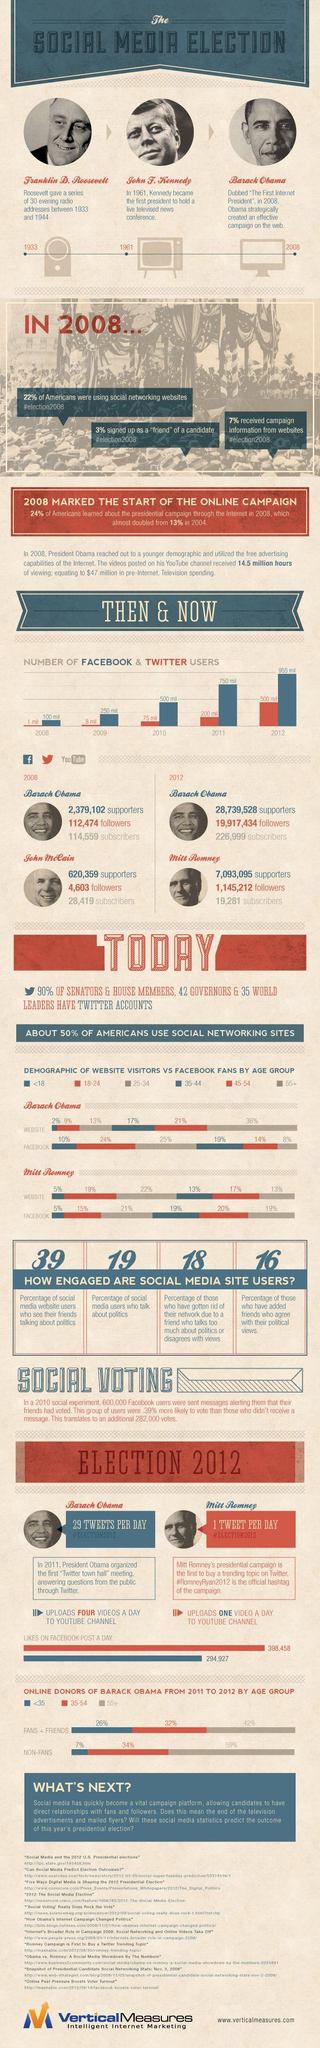Specify some key components in this picture. Approximately 19% of Facebook fans of Mitt Romney were aged between 35-44 and 55+. In 2012, the number of followers that President Obama had on Twitter was 19,804,960. According to data on website visitors for Barack Obama, approximately 21% of visitors were aged between 45-54. In 2012, President Obama had an increase of 112,440 subscribers on his YouTube channel. John F. Kennedy used television as the primary medium for his election campaign. 